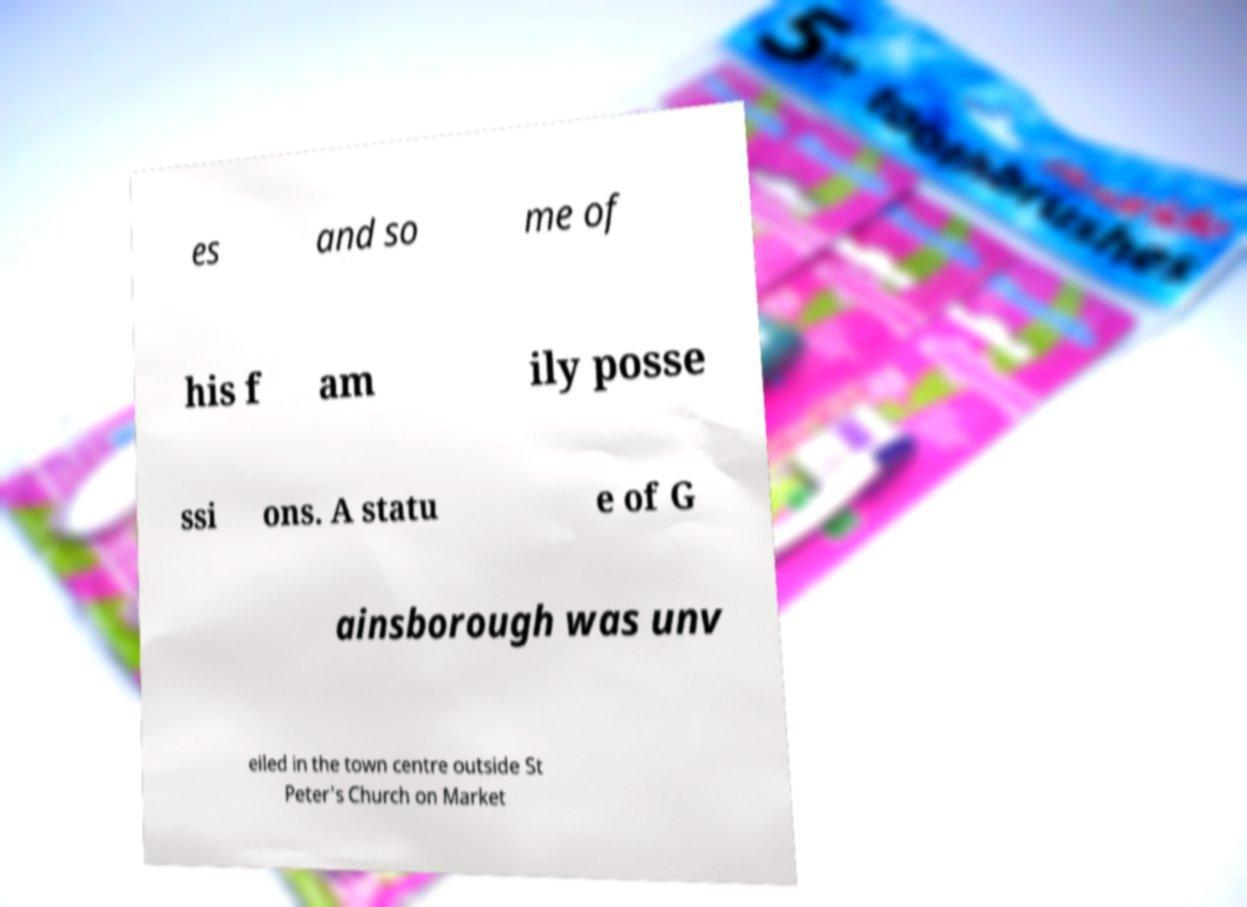There's text embedded in this image that I need extracted. Can you transcribe it verbatim? es and so me of his f am ily posse ssi ons. A statu e of G ainsborough was unv eiled in the town centre outside St Peter's Church on Market 